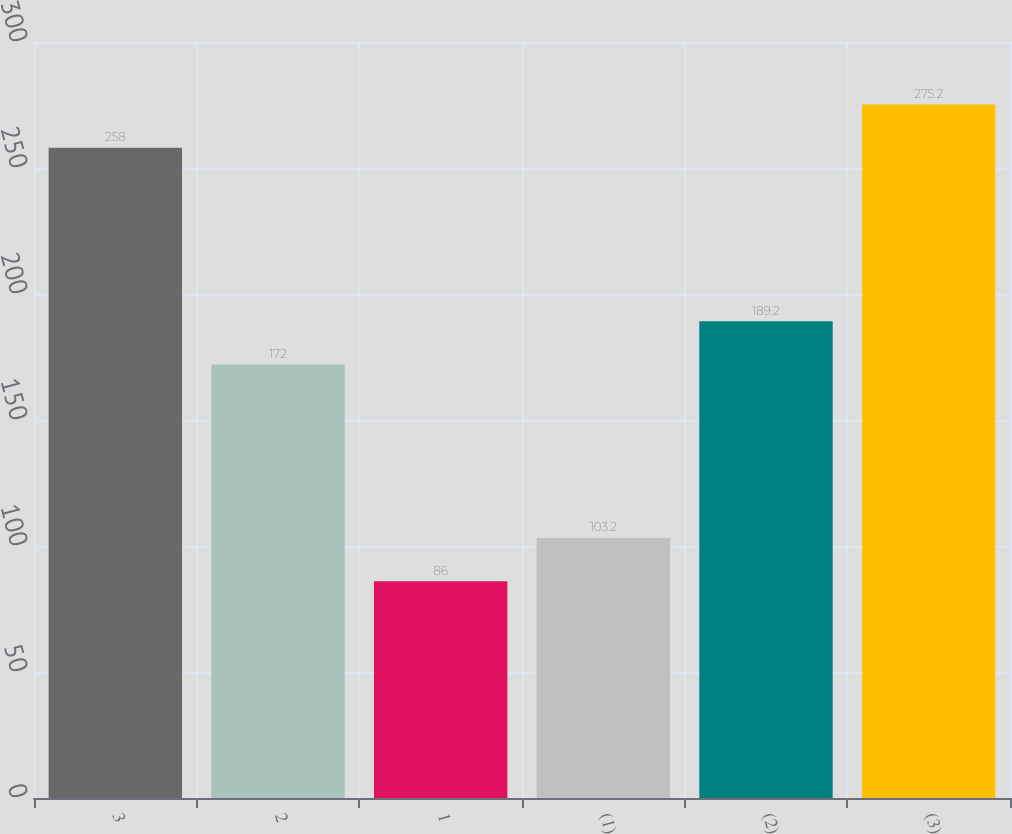<chart> <loc_0><loc_0><loc_500><loc_500><bar_chart><fcel>3<fcel>2<fcel>1<fcel>(1)<fcel>(2)<fcel>(3)<nl><fcel>258<fcel>172<fcel>86<fcel>103.2<fcel>189.2<fcel>275.2<nl></chart> 